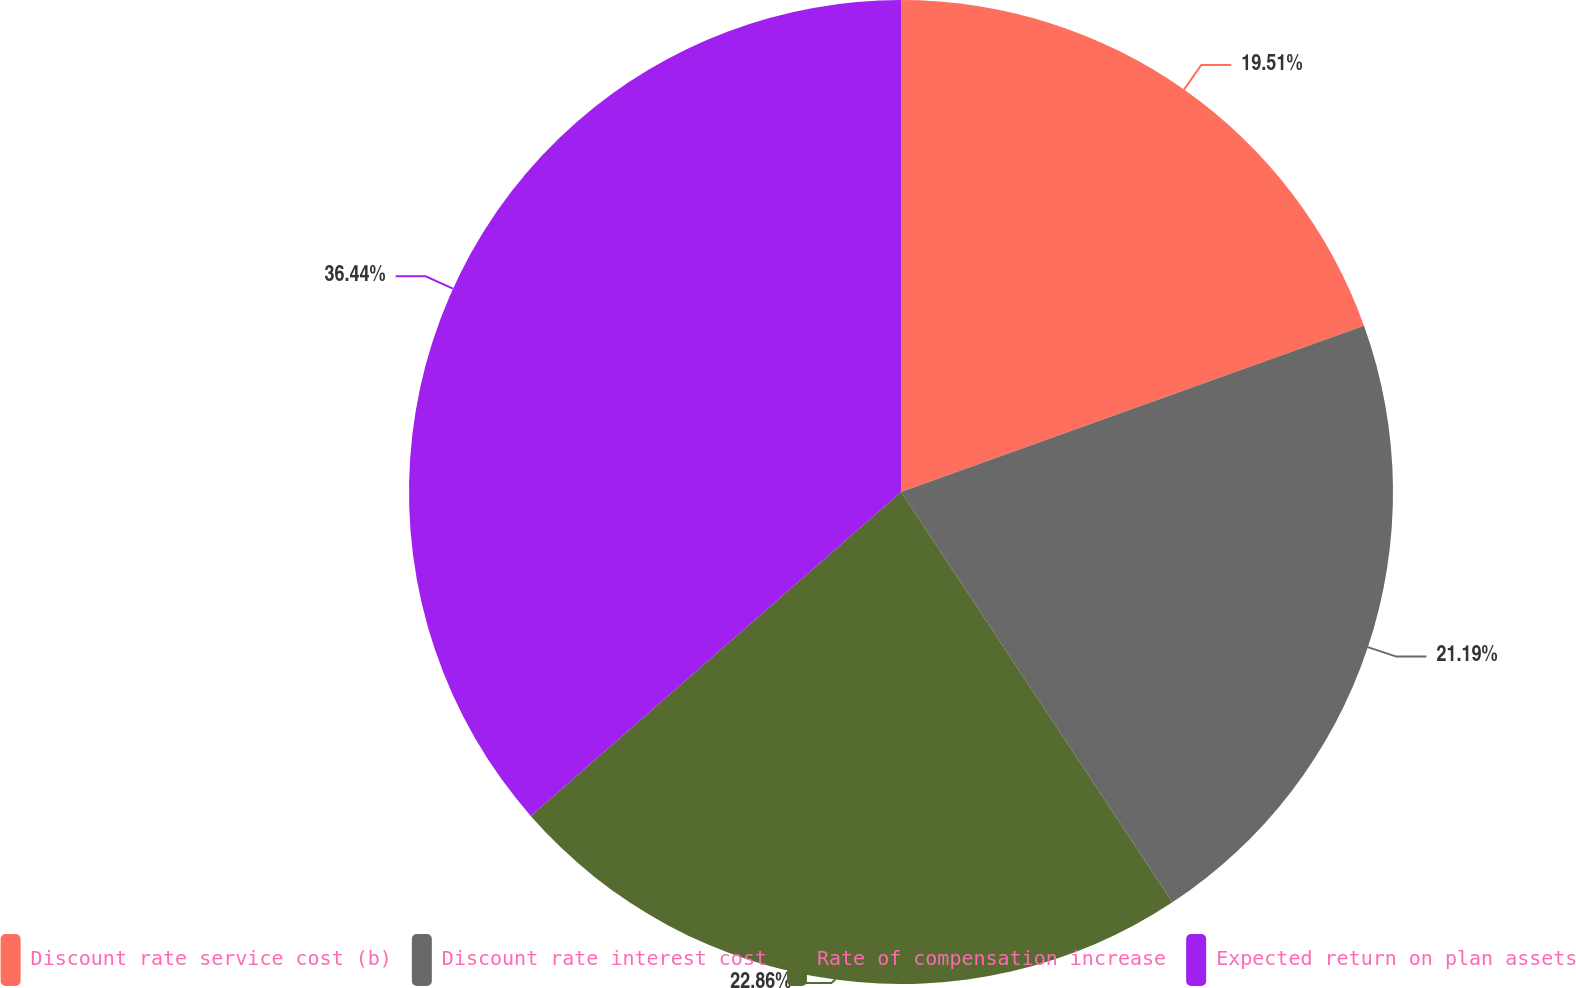Convert chart to OTSL. <chart><loc_0><loc_0><loc_500><loc_500><pie_chart><fcel>Discount rate service cost (b)<fcel>Discount rate interest cost<fcel>Rate of compensation increase<fcel>Expected return on plan assets<nl><fcel>19.51%<fcel>21.19%<fcel>22.86%<fcel>36.44%<nl></chart> 